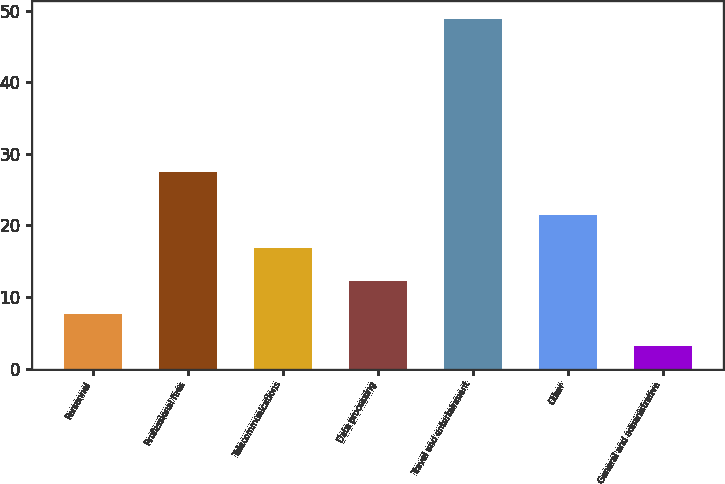Convert chart to OTSL. <chart><loc_0><loc_0><loc_500><loc_500><bar_chart><fcel>Personnel<fcel>Professional fees<fcel>Telecommunications<fcel>Data processing<fcel>Travel and entertainment<fcel>Other<fcel>General and administrative<nl><fcel>7.68<fcel>27.5<fcel>16.84<fcel>12.26<fcel>48.9<fcel>21.42<fcel>3.1<nl></chart> 